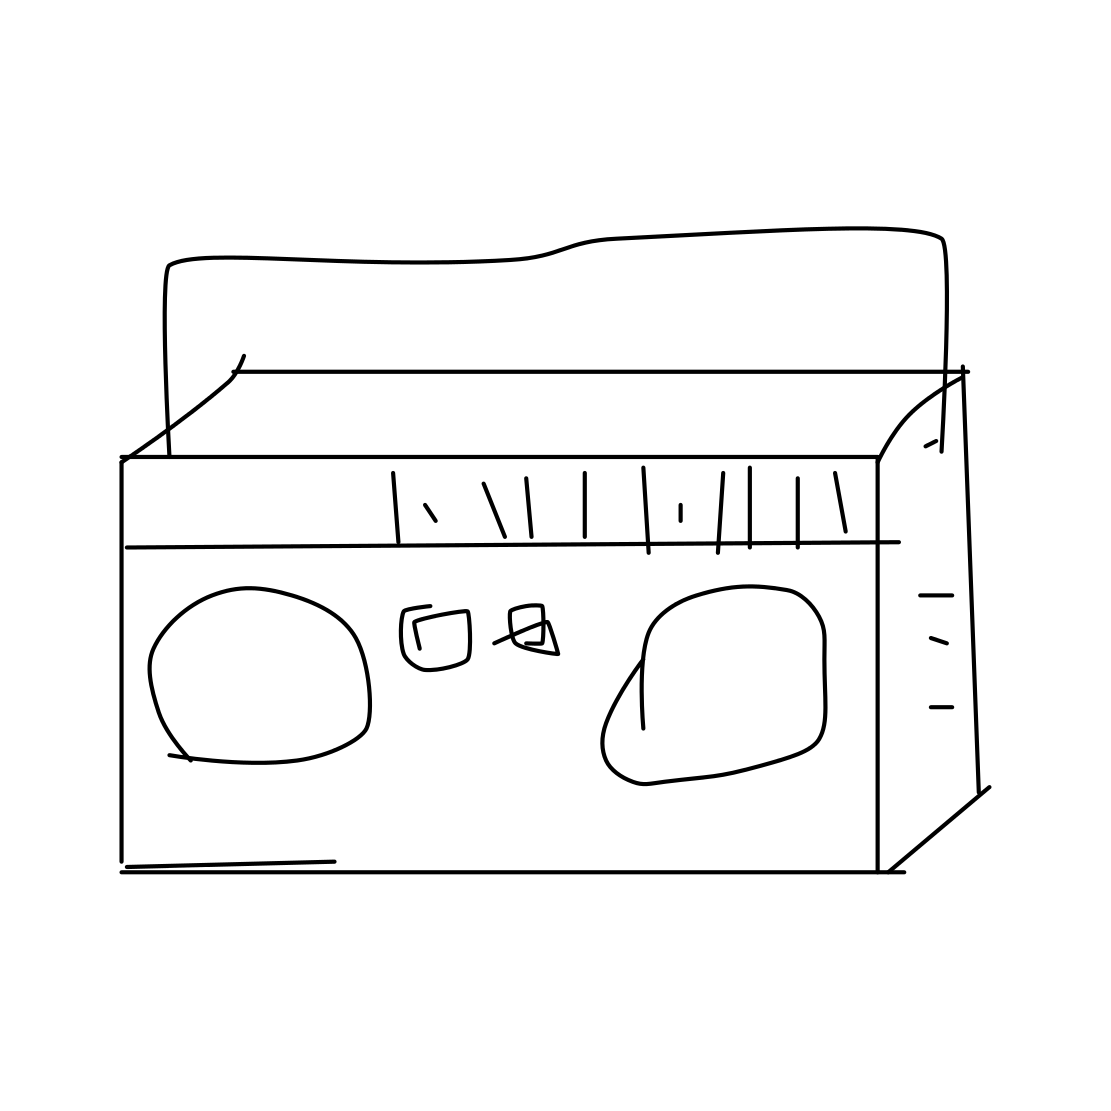What decade is this object associated with? This object, the cassette tape, is most closely associated with the 1970s through the 1990s, when it was a popular medium for audio playback and recording. 